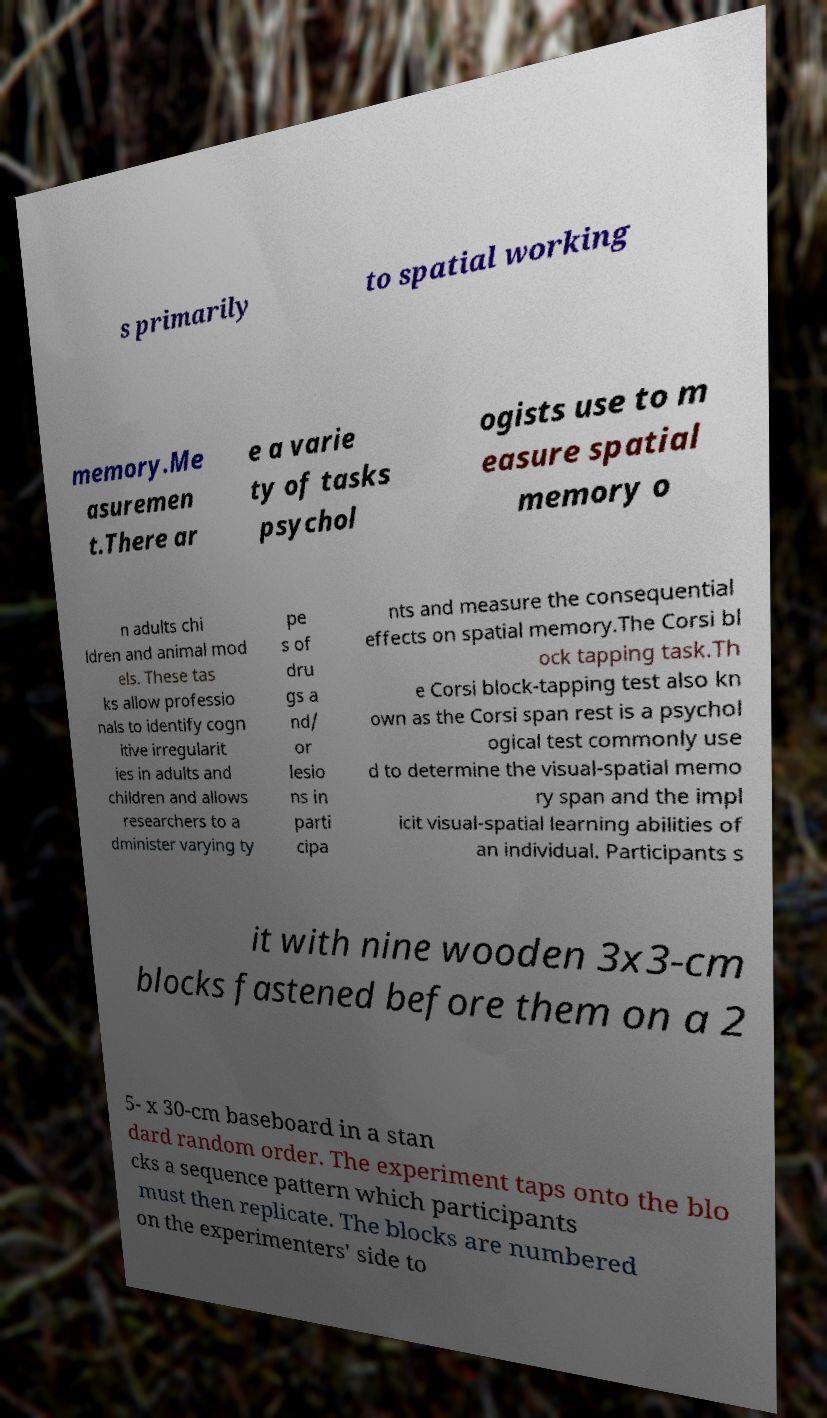Can you read and provide the text displayed in the image?This photo seems to have some interesting text. Can you extract and type it out for me? s primarily to spatial working memory.Me asuremen t.There ar e a varie ty of tasks psychol ogists use to m easure spatial memory o n adults chi ldren and animal mod els. These tas ks allow professio nals to identify cogn itive irregularit ies in adults and children and allows researchers to a dminister varying ty pe s of dru gs a nd/ or lesio ns in parti cipa nts and measure the consequential effects on spatial memory.The Corsi bl ock tapping task.Th e Corsi block-tapping test also kn own as the Corsi span rest is a psychol ogical test commonly use d to determine the visual-spatial memo ry span and the impl icit visual-spatial learning abilities of an individual. Participants s it with nine wooden 3x3-cm blocks fastened before them on a 2 5- x 30-cm baseboard in a stan dard random order. The experiment taps onto the blo cks a sequence pattern which participants must then replicate. The blocks are numbered on the experimenters' side to 